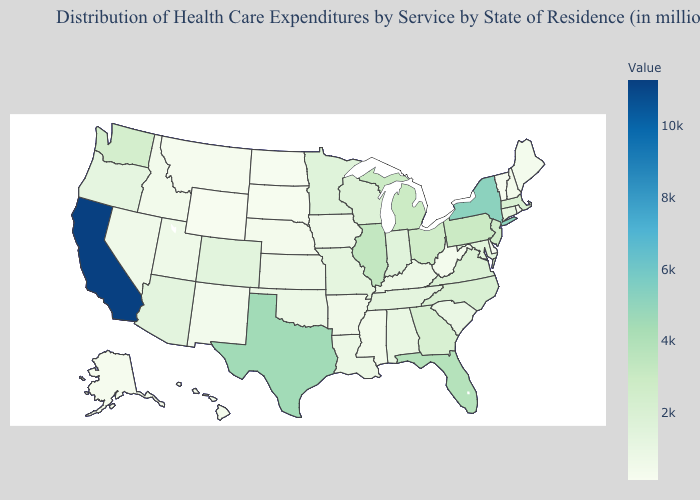Does New York have the lowest value in the Northeast?
Answer briefly. No. Which states have the lowest value in the USA?
Give a very brief answer. Wyoming. Is the legend a continuous bar?
Answer briefly. Yes. Among the states that border Kentucky , does Missouri have the lowest value?
Keep it brief. No. Does California have the highest value in the West?
Give a very brief answer. Yes. Does Delaware have a lower value than Colorado?
Quick response, please. Yes. 